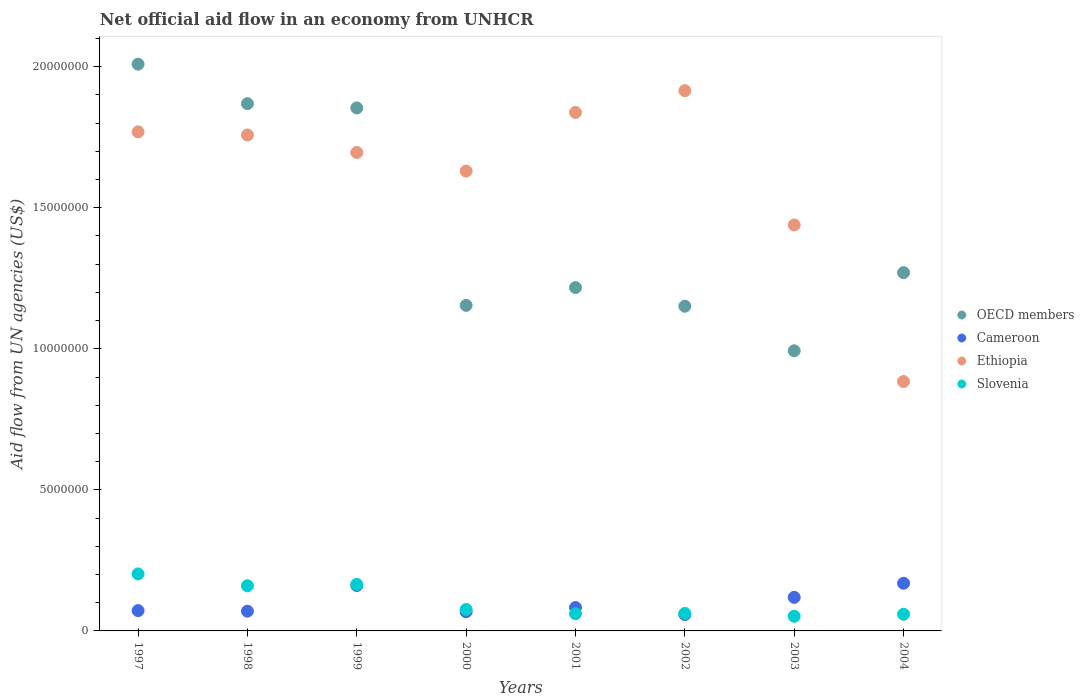Is the number of dotlines equal to the number of legend labels?
Ensure brevity in your answer.  Yes. What is the net official aid flow in Slovenia in 2002?
Keep it short and to the point. 6.20e+05. Across all years, what is the maximum net official aid flow in OECD members?
Your answer should be compact. 2.01e+07. Across all years, what is the minimum net official aid flow in OECD members?
Provide a succinct answer. 9.93e+06. In which year was the net official aid flow in Slovenia maximum?
Make the answer very short. 1997. What is the total net official aid flow in OECD members in the graph?
Provide a succinct answer. 1.15e+08. What is the difference between the net official aid flow in Cameroon in 1999 and that in 2003?
Provide a succinct answer. 4.20e+05. What is the difference between the net official aid flow in Slovenia in 2004 and the net official aid flow in Ethiopia in 1997?
Offer a very short reply. -1.71e+07. In the year 1999, what is the difference between the net official aid flow in OECD members and net official aid flow in Slovenia?
Provide a short and direct response. 1.69e+07. In how many years, is the net official aid flow in Slovenia greater than 10000000 US$?
Ensure brevity in your answer.  0. What is the ratio of the net official aid flow in Cameroon in 1999 to that in 2001?
Provide a short and direct response. 1.94. Is the net official aid flow in Slovenia in 2000 less than that in 2002?
Provide a short and direct response. No. What is the difference between the highest and the second highest net official aid flow in Ethiopia?
Make the answer very short. 7.70e+05. What is the difference between the highest and the lowest net official aid flow in Cameroon?
Make the answer very short. 1.11e+06. Is the sum of the net official aid flow in Cameroon in 1997 and 1998 greater than the maximum net official aid flow in Ethiopia across all years?
Offer a terse response. No. Is it the case that in every year, the sum of the net official aid flow in Slovenia and net official aid flow in OECD members  is greater than the sum of net official aid flow in Cameroon and net official aid flow in Ethiopia?
Your answer should be very brief. Yes. Is it the case that in every year, the sum of the net official aid flow in Slovenia and net official aid flow in Ethiopia  is greater than the net official aid flow in OECD members?
Your response must be concise. No. Is the net official aid flow in Ethiopia strictly greater than the net official aid flow in Cameroon over the years?
Ensure brevity in your answer.  Yes. How many years are there in the graph?
Offer a terse response. 8. Are the values on the major ticks of Y-axis written in scientific E-notation?
Offer a very short reply. No. Where does the legend appear in the graph?
Make the answer very short. Center right. What is the title of the graph?
Provide a succinct answer. Net official aid flow in an economy from UNHCR. Does "Tanzania" appear as one of the legend labels in the graph?
Your response must be concise. No. What is the label or title of the X-axis?
Your answer should be compact. Years. What is the label or title of the Y-axis?
Provide a succinct answer. Aid flow from UN agencies (US$). What is the Aid flow from UN agencies (US$) in OECD members in 1997?
Offer a terse response. 2.01e+07. What is the Aid flow from UN agencies (US$) of Cameroon in 1997?
Your answer should be compact. 7.20e+05. What is the Aid flow from UN agencies (US$) of Ethiopia in 1997?
Your answer should be compact. 1.77e+07. What is the Aid flow from UN agencies (US$) in Slovenia in 1997?
Ensure brevity in your answer.  2.02e+06. What is the Aid flow from UN agencies (US$) in OECD members in 1998?
Provide a succinct answer. 1.87e+07. What is the Aid flow from UN agencies (US$) in Cameroon in 1998?
Keep it short and to the point. 7.00e+05. What is the Aid flow from UN agencies (US$) in Ethiopia in 1998?
Ensure brevity in your answer.  1.76e+07. What is the Aid flow from UN agencies (US$) of Slovenia in 1998?
Your response must be concise. 1.60e+06. What is the Aid flow from UN agencies (US$) in OECD members in 1999?
Ensure brevity in your answer.  1.85e+07. What is the Aid flow from UN agencies (US$) of Cameroon in 1999?
Your answer should be very brief. 1.61e+06. What is the Aid flow from UN agencies (US$) of Ethiopia in 1999?
Keep it short and to the point. 1.70e+07. What is the Aid flow from UN agencies (US$) in Slovenia in 1999?
Give a very brief answer. 1.65e+06. What is the Aid flow from UN agencies (US$) in OECD members in 2000?
Provide a succinct answer. 1.15e+07. What is the Aid flow from UN agencies (US$) of Cameroon in 2000?
Offer a very short reply. 6.80e+05. What is the Aid flow from UN agencies (US$) in Ethiopia in 2000?
Your answer should be compact. 1.63e+07. What is the Aid flow from UN agencies (US$) of Slovenia in 2000?
Provide a succinct answer. 7.60e+05. What is the Aid flow from UN agencies (US$) of OECD members in 2001?
Ensure brevity in your answer.  1.22e+07. What is the Aid flow from UN agencies (US$) in Cameroon in 2001?
Ensure brevity in your answer.  8.30e+05. What is the Aid flow from UN agencies (US$) in Ethiopia in 2001?
Provide a short and direct response. 1.84e+07. What is the Aid flow from UN agencies (US$) in OECD members in 2002?
Offer a terse response. 1.15e+07. What is the Aid flow from UN agencies (US$) in Cameroon in 2002?
Provide a short and direct response. 5.80e+05. What is the Aid flow from UN agencies (US$) in Ethiopia in 2002?
Your answer should be compact. 1.92e+07. What is the Aid flow from UN agencies (US$) in Slovenia in 2002?
Your answer should be compact. 6.20e+05. What is the Aid flow from UN agencies (US$) in OECD members in 2003?
Your answer should be compact. 9.93e+06. What is the Aid flow from UN agencies (US$) of Cameroon in 2003?
Your answer should be very brief. 1.19e+06. What is the Aid flow from UN agencies (US$) in Ethiopia in 2003?
Provide a succinct answer. 1.44e+07. What is the Aid flow from UN agencies (US$) in Slovenia in 2003?
Make the answer very short. 5.20e+05. What is the Aid flow from UN agencies (US$) of OECD members in 2004?
Provide a succinct answer. 1.27e+07. What is the Aid flow from UN agencies (US$) in Cameroon in 2004?
Give a very brief answer. 1.69e+06. What is the Aid flow from UN agencies (US$) of Ethiopia in 2004?
Provide a short and direct response. 8.84e+06. What is the Aid flow from UN agencies (US$) in Slovenia in 2004?
Offer a very short reply. 5.90e+05. Across all years, what is the maximum Aid flow from UN agencies (US$) of OECD members?
Provide a succinct answer. 2.01e+07. Across all years, what is the maximum Aid flow from UN agencies (US$) in Cameroon?
Make the answer very short. 1.69e+06. Across all years, what is the maximum Aid flow from UN agencies (US$) of Ethiopia?
Provide a succinct answer. 1.92e+07. Across all years, what is the maximum Aid flow from UN agencies (US$) of Slovenia?
Offer a very short reply. 2.02e+06. Across all years, what is the minimum Aid flow from UN agencies (US$) in OECD members?
Provide a succinct answer. 9.93e+06. Across all years, what is the minimum Aid flow from UN agencies (US$) of Cameroon?
Your answer should be compact. 5.80e+05. Across all years, what is the minimum Aid flow from UN agencies (US$) in Ethiopia?
Your answer should be compact. 8.84e+06. Across all years, what is the minimum Aid flow from UN agencies (US$) in Slovenia?
Give a very brief answer. 5.20e+05. What is the total Aid flow from UN agencies (US$) in OECD members in the graph?
Ensure brevity in your answer.  1.15e+08. What is the total Aid flow from UN agencies (US$) in Ethiopia in the graph?
Your response must be concise. 1.29e+08. What is the total Aid flow from UN agencies (US$) in Slovenia in the graph?
Offer a very short reply. 8.37e+06. What is the difference between the Aid flow from UN agencies (US$) of OECD members in 1997 and that in 1998?
Provide a short and direct response. 1.40e+06. What is the difference between the Aid flow from UN agencies (US$) in Slovenia in 1997 and that in 1998?
Keep it short and to the point. 4.20e+05. What is the difference between the Aid flow from UN agencies (US$) of OECD members in 1997 and that in 1999?
Provide a succinct answer. 1.55e+06. What is the difference between the Aid flow from UN agencies (US$) in Cameroon in 1997 and that in 1999?
Make the answer very short. -8.90e+05. What is the difference between the Aid flow from UN agencies (US$) in Ethiopia in 1997 and that in 1999?
Ensure brevity in your answer.  7.30e+05. What is the difference between the Aid flow from UN agencies (US$) of OECD members in 1997 and that in 2000?
Offer a very short reply. 8.55e+06. What is the difference between the Aid flow from UN agencies (US$) of Cameroon in 1997 and that in 2000?
Your response must be concise. 4.00e+04. What is the difference between the Aid flow from UN agencies (US$) of Ethiopia in 1997 and that in 2000?
Keep it short and to the point. 1.39e+06. What is the difference between the Aid flow from UN agencies (US$) in Slovenia in 1997 and that in 2000?
Keep it short and to the point. 1.26e+06. What is the difference between the Aid flow from UN agencies (US$) of OECD members in 1997 and that in 2001?
Keep it short and to the point. 7.92e+06. What is the difference between the Aid flow from UN agencies (US$) in Cameroon in 1997 and that in 2001?
Give a very brief answer. -1.10e+05. What is the difference between the Aid flow from UN agencies (US$) of Ethiopia in 1997 and that in 2001?
Ensure brevity in your answer.  -6.90e+05. What is the difference between the Aid flow from UN agencies (US$) in Slovenia in 1997 and that in 2001?
Your response must be concise. 1.41e+06. What is the difference between the Aid flow from UN agencies (US$) of OECD members in 1997 and that in 2002?
Offer a terse response. 8.58e+06. What is the difference between the Aid flow from UN agencies (US$) in Ethiopia in 1997 and that in 2002?
Offer a very short reply. -1.46e+06. What is the difference between the Aid flow from UN agencies (US$) in Slovenia in 1997 and that in 2002?
Offer a terse response. 1.40e+06. What is the difference between the Aid flow from UN agencies (US$) of OECD members in 1997 and that in 2003?
Give a very brief answer. 1.02e+07. What is the difference between the Aid flow from UN agencies (US$) in Cameroon in 1997 and that in 2003?
Provide a succinct answer. -4.70e+05. What is the difference between the Aid flow from UN agencies (US$) in Ethiopia in 1997 and that in 2003?
Provide a succinct answer. 3.30e+06. What is the difference between the Aid flow from UN agencies (US$) in Slovenia in 1997 and that in 2003?
Offer a terse response. 1.50e+06. What is the difference between the Aid flow from UN agencies (US$) of OECD members in 1997 and that in 2004?
Make the answer very short. 7.39e+06. What is the difference between the Aid flow from UN agencies (US$) of Cameroon in 1997 and that in 2004?
Offer a terse response. -9.70e+05. What is the difference between the Aid flow from UN agencies (US$) of Ethiopia in 1997 and that in 2004?
Keep it short and to the point. 8.85e+06. What is the difference between the Aid flow from UN agencies (US$) in Slovenia in 1997 and that in 2004?
Offer a terse response. 1.43e+06. What is the difference between the Aid flow from UN agencies (US$) of OECD members in 1998 and that in 1999?
Your answer should be compact. 1.50e+05. What is the difference between the Aid flow from UN agencies (US$) in Cameroon in 1998 and that in 1999?
Give a very brief answer. -9.10e+05. What is the difference between the Aid flow from UN agencies (US$) of Ethiopia in 1998 and that in 1999?
Make the answer very short. 6.20e+05. What is the difference between the Aid flow from UN agencies (US$) of OECD members in 1998 and that in 2000?
Your response must be concise. 7.15e+06. What is the difference between the Aid flow from UN agencies (US$) in Ethiopia in 1998 and that in 2000?
Your answer should be compact. 1.28e+06. What is the difference between the Aid flow from UN agencies (US$) of Slovenia in 1998 and that in 2000?
Offer a terse response. 8.40e+05. What is the difference between the Aid flow from UN agencies (US$) in OECD members in 1998 and that in 2001?
Your response must be concise. 6.52e+06. What is the difference between the Aid flow from UN agencies (US$) in Cameroon in 1998 and that in 2001?
Keep it short and to the point. -1.30e+05. What is the difference between the Aid flow from UN agencies (US$) in Ethiopia in 1998 and that in 2001?
Make the answer very short. -8.00e+05. What is the difference between the Aid flow from UN agencies (US$) in Slovenia in 1998 and that in 2001?
Your answer should be very brief. 9.90e+05. What is the difference between the Aid flow from UN agencies (US$) in OECD members in 1998 and that in 2002?
Your answer should be very brief. 7.18e+06. What is the difference between the Aid flow from UN agencies (US$) of Ethiopia in 1998 and that in 2002?
Give a very brief answer. -1.57e+06. What is the difference between the Aid flow from UN agencies (US$) in Slovenia in 1998 and that in 2002?
Offer a very short reply. 9.80e+05. What is the difference between the Aid flow from UN agencies (US$) of OECD members in 1998 and that in 2003?
Offer a terse response. 8.76e+06. What is the difference between the Aid flow from UN agencies (US$) in Cameroon in 1998 and that in 2003?
Keep it short and to the point. -4.90e+05. What is the difference between the Aid flow from UN agencies (US$) of Ethiopia in 1998 and that in 2003?
Ensure brevity in your answer.  3.19e+06. What is the difference between the Aid flow from UN agencies (US$) of Slovenia in 1998 and that in 2003?
Give a very brief answer. 1.08e+06. What is the difference between the Aid flow from UN agencies (US$) of OECD members in 1998 and that in 2004?
Ensure brevity in your answer.  5.99e+06. What is the difference between the Aid flow from UN agencies (US$) in Cameroon in 1998 and that in 2004?
Offer a very short reply. -9.90e+05. What is the difference between the Aid flow from UN agencies (US$) in Ethiopia in 1998 and that in 2004?
Your answer should be compact. 8.74e+06. What is the difference between the Aid flow from UN agencies (US$) of Slovenia in 1998 and that in 2004?
Your answer should be very brief. 1.01e+06. What is the difference between the Aid flow from UN agencies (US$) in Cameroon in 1999 and that in 2000?
Your answer should be compact. 9.30e+05. What is the difference between the Aid flow from UN agencies (US$) in Ethiopia in 1999 and that in 2000?
Your answer should be very brief. 6.60e+05. What is the difference between the Aid flow from UN agencies (US$) of Slovenia in 1999 and that in 2000?
Your answer should be compact. 8.90e+05. What is the difference between the Aid flow from UN agencies (US$) of OECD members in 1999 and that in 2001?
Provide a short and direct response. 6.37e+06. What is the difference between the Aid flow from UN agencies (US$) of Cameroon in 1999 and that in 2001?
Your answer should be very brief. 7.80e+05. What is the difference between the Aid flow from UN agencies (US$) of Ethiopia in 1999 and that in 2001?
Ensure brevity in your answer.  -1.42e+06. What is the difference between the Aid flow from UN agencies (US$) in Slovenia in 1999 and that in 2001?
Your answer should be very brief. 1.04e+06. What is the difference between the Aid flow from UN agencies (US$) in OECD members in 1999 and that in 2002?
Ensure brevity in your answer.  7.03e+06. What is the difference between the Aid flow from UN agencies (US$) of Cameroon in 1999 and that in 2002?
Make the answer very short. 1.03e+06. What is the difference between the Aid flow from UN agencies (US$) in Ethiopia in 1999 and that in 2002?
Offer a terse response. -2.19e+06. What is the difference between the Aid flow from UN agencies (US$) of Slovenia in 1999 and that in 2002?
Your answer should be very brief. 1.03e+06. What is the difference between the Aid flow from UN agencies (US$) in OECD members in 1999 and that in 2003?
Provide a succinct answer. 8.61e+06. What is the difference between the Aid flow from UN agencies (US$) of Ethiopia in 1999 and that in 2003?
Your answer should be compact. 2.57e+06. What is the difference between the Aid flow from UN agencies (US$) in Slovenia in 1999 and that in 2003?
Provide a short and direct response. 1.13e+06. What is the difference between the Aid flow from UN agencies (US$) of OECD members in 1999 and that in 2004?
Your answer should be compact. 5.84e+06. What is the difference between the Aid flow from UN agencies (US$) of Cameroon in 1999 and that in 2004?
Your response must be concise. -8.00e+04. What is the difference between the Aid flow from UN agencies (US$) in Ethiopia in 1999 and that in 2004?
Ensure brevity in your answer.  8.12e+06. What is the difference between the Aid flow from UN agencies (US$) of Slovenia in 1999 and that in 2004?
Provide a short and direct response. 1.06e+06. What is the difference between the Aid flow from UN agencies (US$) of OECD members in 2000 and that in 2001?
Provide a short and direct response. -6.30e+05. What is the difference between the Aid flow from UN agencies (US$) in Ethiopia in 2000 and that in 2001?
Make the answer very short. -2.08e+06. What is the difference between the Aid flow from UN agencies (US$) of Cameroon in 2000 and that in 2002?
Provide a short and direct response. 1.00e+05. What is the difference between the Aid flow from UN agencies (US$) of Ethiopia in 2000 and that in 2002?
Offer a very short reply. -2.85e+06. What is the difference between the Aid flow from UN agencies (US$) in OECD members in 2000 and that in 2003?
Your response must be concise. 1.61e+06. What is the difference between the Aid flow from UN agencies (US$) of Cameroon in 2000 and that in 2003?
Offer a very short reply. -5.10e+05. What is the difference between the Aid flow from UN agencies (US$) of Ethiopia in 2000 and that in 2003?
Give a very brief answer. 1.91e+06. What is the difference between the Aid flow from UN agencies (US$) of OECD members in 2000 and that in 2004?
Your answer should be very brief. -1.16e+06. What is the difference between the Aid flow from UN agencies (US$) of Cameroon in 2000 and that in 2004?
Keep it short and to the point. -1.01e+06. What is the difference between the Aid flow from UN agencies (US$) of Ethiopia in 2000 and that in 2004?
Offer a very short reply. 7.46e+06. What is the difference between the Aid flow from UN agencies (US$) of Slovenia in 2000 and that in 2004?
Provide a succinct answer. 1.70e+05. What is the difference between the Aid flow from UN agencies (US$) in Ethiopia in 2001 and that in 2002?
Ensure brevity in your answer.  -7.70e+05. What is the difference between the Aid flow from UN agencies (US$) in OECD members in 2001 and that in 2003?
Provide a succinct answer. 2.24e+06. What is the difference between the Aid flow from UN agencies (US$) in Cameroon in 2001 and that in 2003?
Make the answer very short. -3.60e+05. What is the difference between the Aid flow from UN agencies (US$) in Ethiopia in 2001 and that in 2003?
Keep it short and to the point. 3.99e+06. What is the difference between the Aid flow from UN agencies (US$) in OECD members in 2001 and that in 2004?
Provide a short and direct response. -5.30e+05. What is the difference between the Aid flow from UN agencies (US$) in Cameroon in 2001 and that in 2004?
Keep it short and to the point. -8.60e+05. What is the difference between the Aid flow from UN agencies (US$) of Ethiopia in 2001 and that in 2004?
Your answer should be compact. 9.54e+06. What is the difference between the Aid flow from UN agencies (US$) of Slovenia in 2001 and that in 2004?
Give a very brief answer. 2.00e+04. What is the difference between the Aid flow from UN agencies (US$) in OECD members in 2002 and that in 2003?
Ensure brevity in your answer.  1.58e+06. What is the difference between the Aid flow from UN agencies (US$) of Cameroon in 2002 and that in 2003?
Offer a very short reply. -6.10e+05. What is the difference between the Aid flow from UN agencies (US$) of Ethiopia in 2002 and that in 2003?
Ensure brevity in your answer.  4.76e+06. What is the difference between the Aid flow from UN agencies (US$) in OECD members in 2002 and that in 2004?
Provide a short and direct response. -1.19e+06. What is the difference between the Aid flow from UN agencies (US$) in Cameroon in 2002 and that in 2004?
Provide a succinct answer. -1.11e+06. What is the difference between the Aid flow from UN agencies (US$) in Ethiopia in 2002 and that in 2004?
Keep it short and to the point. 1.03e+07. What is the difference between the Aid flow from UN agencies (US$) of Slovenia in 2002 and that in 2004?
Provide a succinct answer. 3.00e+04. What is the difference between the Aid flow from UN agencies (US$) of OECD members in 2003 and that in 2004?
Your response must be concise. -2.77e+06. What is the difference between the Aid flow from UN agencies (US$) of Cameroon in 2003 and that in 2004?
Your answer should be compact. -5.00e+05. What is the difference between the Aid flow from UN agencies (US$) in Ethiopia in 2003 and that in 2004?
Offer a terse response. 5.55e+06. What is the difference between the Aid flow from UN agencies (US$) of OECD members in 1997 and the Aid flow from UN agencies (US$) of Cameroon in 1998?
Offer a very short reply. 1.94e+07. What is the difference between the Aid flow from UN agencies (US$) of OECD members in 1997 and the Aid flow from UN agencies (US$) of Ethiopia in 1998?
Give a very brief answer. 2.51e+06. What is the difference between the Aid flow from UN agencies (US$) of OECD members in 1997 and the Aid flow from UN agencies (US$) of Slovenia in 1998?
Provide a succinct answer. 1.85e+07. What is the difference between the Aid flow from UN agencies (US$) of Cameroon in 1997 and the Aid flow from UN agencies (US$) of Ethiopia in 1998?
Give a very brief answer. -1.69e+07. What is the difference between the Aid flow from UN agencies (US$) in Cameroon in 1997 and the Aid flow from UN agencies (US$) in Slovenia in 1998?
Your answer should be very brief. -8.80e+05. What is the difference between the Aid flow from UN agencies (US$) of Ethiopia in 1997 and the Aid flow from UN agencies (US$) of Slovenia in 1998?
Your answer should be compact. 1.61e+07. What is the difference between the Aid flow from UN agencies (US$) of OECD members in 1997 and the Aid flow from UN agencies (US$) of Cameroon in 1999?
Offer a terse response. 1.85e+07. What is the difference between the Aid flow from UN agencies (US$) of OECD members in 1997 and the Aid flow from UN agencies (US$) of Ethiopia in 1999?
Offer a very short reply. 3.13e+06. What is the difference between the Aid flow from UN agencies (US$) in OECD members in 1997 and the Aid flow from UN agencies (US$) in Slovenia in 1999?
Your answer should be compact. 1.84e+07. What is the difference between the Aid flow from UN agencies (US$) of Cameroon in 1997 and the Aid flow from UN agencies (US$) of Ethiopia in 1999?
Your response must be concise. -1.62e+07. What is the difference between the Aid flow from UN agencies (US$) of Cameroon in 1997 and the Aid flow from UN agencies (US$) of Slovenia in 1999?
Your response must be concise. -9.30e+05. What is the difference between the Aid flow from UN agencies (US$) of Ethiopia in 1997 and the Aid flow from UN agencies (US$) of Slovenia in 1999?
Provide a short and direct response. 1.60e+07. What is the difference between the Aid flow from UN agencies (US$) in OECD members in 1997 and the Aid flow from UN agencies (US$) in Cameroon in 2000?
Provide a short and direct response. 1.94e+07. What is the difference between the Aid flow from UN agencies (US$) of OECD members in 1997 and the Aid flow from UN agencies (US$) of Ethiopia in 2000?
Your answer should be very brief. 3.79e+06. What is the difference between the Aid flow from UN agencies (US$) in OECD members in 1997 and the Aid flow from UN agencies (US$) in Slovenia in 2000?
Offer a terse response. 1.93e+07. What is the difference between the Aid flow from UN agencies (US$) in Cameroon in 1997 and the Aid flow from UN agencies (US$) in Ethiopia in 2000?
Your answer should be compact. -1.56e+07. What is the difference between the Aid flow from UN agencies (US$) of Cameroon in 1997 and the Aid flow from UN agencies (US$) of Slovenia in 2000?
Your response must be concise. -4.00e+04. What is the difference between the Aid flow from UN agencies (US$) of Ethiopia in 1997 and the Aid flow from UN agencies (US$) of Slovenia in 2000?
Give a very brief answer. 1.69e+07. What is the difference between the Aid flow from UN agencies (US$) of OECD members in 1997 and the Aid flow from UN agencies (US$) of Cameroon in 2001?
Provide a short and direct response. 1.93e+07. What is the difference between the Aid flow from UN agencies (US$) in OECD members in 1997 and the Aid flow from UN agencies (US$) in Ethiopia in 2001?
Your response must be concise. 1.71e+06. What is the difference between the Aid flow from UN agencies (US$) of OECD members in 1997 and the Aid flow from UN agencies (US$) of Slovenia in 2001?
Provide a succinct answer. 1.95e+07. What is the difference between the Aid flow from UN agencies (US$) in Cameroon in 1997 and the Aid flow from UN agencies (US$) in Ethiopia in 2001?
Your answer should be very brief. -1.77e+07. What is the difference between the Aid flow from UN agencies (US$) of Cameroon in 1997 and the Aid flow from UN agencies (US$) of Slovenia in 2001?
Offer a terse response. 1.10e+05. What is the difference between the Aid flow from UN agencies (US$) in Ethiopia in 1997 and the Aid flow from UN agencies (US$) in Slovenia in 2001?
Your answer should be compact. 1.71e+07. What is the difference between the Aid flow from UN agencies (US$) of OECD members in 1997 and the Aid flow from UN agencies (US$) of Cameroon in 2002?
Make the answer very short. 1.95e+07. What is the difference between the Aid flow from UN agencies (US$) in OECD members in 1997 and the Aid flow from UN agencies (US$) in Ethiopia in 2002?
Offer a very short reply. 9.40e+05. What is the difference between the Aid flow from UN agencies (US$) in OECD members in 1997 and the Aid flow from UN agencies (US$) in Slovenia in 2002?
Keep it short and to the point. 1.95e+07. What is the difference between the Aid flow from UN agencies (US$) in Cameroon in 1997 and the Aid flow from UN agencies (US$) in Ethiopia in 2002?
Keep it short and to the point. -1.84e+07. What is the difference between the Aid flow from UN agencies (US$) in Cameroon in 1997 and the Aid flow from UN agencies (US$) in Slovenia in 2002?
Keep it short and to the point. 1.00e+05. What is the difference between the Aid flow from UN agencies (US$) in Ethiopia in 1997 and the Aid flow from UN agencies (US$) in Slovenia in 2002?
Provide a succinct answer. 1.71e+07. What is the difference between the Aid flow from UN agencies (US$) of OECD members in 1997 and the Aid flow from UN agencies (US$) of Cameroon in 2003?
Your response must be concise. 1.89e+07. What is the difference between the Aid flow from UN agencies (US$) of OECD members in 1997 and the Aid flow from UN agencies (US$) of Ethiopia in 2003?
Make the answer very short. 5.70e+06. What is the difference between the Aid flow from UN agencies (US$) in OECD members in 1997 and the Aid flow from UN agencies (US$) in Slovenia in 2003?
Your answer should be compact. 1.96e+07. What is the difference between the Aid flow from UN agencies (US$) in Cameroon in 1997 and the Aid flow from UN agencies (US$) in Ethiopia in 2003?
Provide a succinct answer. -1.37e+07. What is the difference between the Aid flow from UN agencies (US$) of Cameroon in 1997 and the Aid flow from UN agencies (US$) of Slovenia in 2003?
Ensure brevity in your answer.  2.00e+05. What is the difference between the Aid flow from UN agencies (US$) in Ethiopia in 1997 and the Aid flow from UN agencies (US$) in Slovenia in 2003?
Your response must be concise. 1.72e+07. What is the difference between the Aid flow from UN agencies (US$) in OECD members in 1997 and the Aid flow from UN agencies (US$) in Cameroon in 2004?
Provide a short and direct response. 1.84e+07. What is the difference between the Aid flow from UN agencies (US$) in OECD members in 1997 and the Aid flow from UN agencies (US$) in Ethiopia in 2004?
Give a very brief answer. 1.12e+07. What is the difference between the Aid flow from UN agencies (US$) in OECD members in 1997 and the Aid flow from UN agencies (US$) in Slovenia in 2004?
Provide a short and direct response. 1.95e+07. What is the difference between the Aid flow from UN agencies (US$) in Cameroon in 1997 and the Aid flow from UN agencies (US$) in Ethiopia in 2004?
Provide a short and direct response. -8.12e+06. What is the difference between the Aid flow from UN agencies (US$) in Ethiopia in 1997 and the Aid flow from UN agencies (US$) in Slovenia in 2004?
Your answer should be very brief. 1.71e+07. What is the difference between the Aid flow from UN agencies (US$) of OECD members in 1998 and the Aid flow from UN agencies (US$) of Cameroon in 1999?
Ensure brevity in your answer.  1.71e+07. What is the difference between the Aid flow from UN agencies (US$) in OECD members in 1998 and the Aid flow from UN agencies (US$) in Ethiopia in 1999?
Provide a short and direct response. 1.73e+06. What is the difference between the Aid flow from UN agencies (US$) of OECD members in 1998 and the Aid flow from UN agencies (US$) of Slovenia in 1999?
Offer a terse response. 1.70e+07. What is the difference between the Aid flow from UN agencies (US$) in Cameroon in 1998 and the Aid flow from UN agencies (US$) in Ethiopia in 1999?
Give a very brief answer. -1.63e+07. What is the difference between the Aid flow from UN agencies (US$) of Cameroon in 1998 and the Aid flow from UN agencies (US$) of Slovenia in 1999?
Offer a very short reply. -9.50e+05. What is the difference between the Aid flow from UN agencies (US$) of Ethiopia in 1998 and the Aid flow from UN agencies (US$) of Slovenia in 1999?
Provide a short and direct response. 1.59e+07. What is the difference between the Aid flow from UN agencies (US$) of OECD members in 1998 and the Aid flow from UN agencies (US$) of Cameroon in 2000?
Provide a succinct answer. 1.80e+07. What is the difference between the Aid flow from UN agencies (US$) in OECD members in 1998 and the Aid flow from UN agencies (US$) in Ethiopia in 2000?
Provide a short and direct response. 2.39e+06. What is the difference between the Aid flow from UN agencies (US$) in OECD members in 1998 and the Aid flow from UN agencies (US$) in Slovenia in 2000?
Your answer should be very brief. 1.79e+07. What is the difference between the Aid flow from UN agencies (US$) of Cameroon in 1998 and the Aid flow from UN agencies (US$) of Ethiopia in 2000?
Offer a very short reply. -1.56e+07. What is the difference between the Aid flow from UN agencies (US$) of Cameroon in 1998 and the Aid flow from UN agencies (US$) of Slovenia in 2000?
Your response must be concise. -6.00e+04. What is the difference between the Aid flow from UN agencies (US$) of Ethiopia in 1998 and the Aid flow from UN agencies (US$) of Slovenia in 2000?
Provide a succinct answer. 1.68e+07. What is the difference between the Aid flow from UN agencies (US$) in OECD members in 1998 and the Aid flow from UN agencies (US$) in Cameroon in 2001?
Give a very brief answer. 1.79e+07. What is the difference between the Aid flow from UN agencies (US$) in OECD members in 1998 and the Aid flow from UN agencies (US$) in Slovenia in 2001?
Your answer should be very brief. 1.81e+07. What is the difference between the Aid flow from UN agencies (US$) in Cameroon in 1998 and the Aid flow from UN agencies (US$) in Ethiopia in 2001?
Keep it short and to the point. -1.77e+07. What is the difference between the Aid flow from UN agencies (US$) in Cameroon in 1998 and the Aid flow from UN agencies (US$) in Slovenia in 2001?
Your answer should be compact. 9.00e+04. What is the difference between the Aid flow from UN agencies (US$) of Ethiopia in 1998 and the Aid flow from UN agencies (US$) of Slovenia in 2001?
Your answer should be very brief. 1.70e+07. What is the difference between the Aid flow from UN agencies (US$) of OECD members in 1998 and the Aid flow from UN agencies (US$) of Cameroon in 2002?
Give a very brief answer. 1.81e+07. What is the difference between the Aid flow from UN agencies (US$) of OECD members in 1998 and the Aid flow from UN agencies (US$) of Ethiopia in 2002?
Your answer should be very brief. -4.60e+05. What is the difference between the Aid flow from UN agencies (US$) in OECD members in 1998 and the Aid flow from UN agencies (US$) in Slovenia in 2002?
Ensure brevity in your answer.  1.81e+07. What is the difference between the Aid flow from UN agencies (US$) of Cameroon in 1998 and the Aid flow from UN agencies (US$) of Ethiopia in 2002?
Keep it short and to the point. -1.84e+07. What is the difference between the Aid flow from UN agencies (US$) in Ethiopia in 1998 and the Aid flow from UN agencies (US$) in Slovenia in 2002?
Make the answer very short. 1.70e+07. What is the difference between the Aid flow from UN agencies (US$) in OECD members in 1998 and the Aid flow from UN agencies (US$) in Cameroon in 2003?
Offer a very short reply. 1.75e+07. What is the difference between the Aid flow from UN agencies (US$) of OECD members in 1998 and the Aid flow from UN agencies (US$) of Ethiopia in 2003?
Your response must be concise. 4.30e+06. What is the difference between the Aid flow from UN agencies (US$) of OECD members in 1998 and the Aid flow from UN agencies (US$) of Slovenia in 2003?
Your answer should be compact. 1.82e+07. What is the difference between the Aid flow from UN agencies (US$) in Cameroon in 1998 and the Aid flow from UN agencies (US$) in Ethiopia in 2003?
Provide a short and direct response. -1.37e+07. What is the difference between the Aid flow from UN agencies (US$) of Ethiopia in 1998 and the Aid flow from UN agencies (US$) of Slovenia in 2003?
Provide a succinct answer. 1.71e+07. What is the difference between the Aid flow from UN agencies (US$) in OECD members in 1998 and the Aid flow from UN agencies (US$) in Cameroon in 2004?
Your answer should be very brief. 1.70e+07. What is the difference between the Aid flow from UN agencies (US$) in OECD members in 1998 and the Aid flow from UN agencies (US$) in Ethiopia in 2004?
Ensure brevity in your answer.  9.85e+06. What is the difference between the Aid flow from UN agencies (US$) of OECD members in 1998 and the Aid flow from UN agencies (US$) of Slovenia in 2004?
Ensure brevity in your answer.  1.81e+07. What is the difference between the Aid flow from UN agencies (US$) in Cameroon in 1998 and the Aid flow from UN agencies (US$) in Ethiopia in 2004?
Offer a terse response. -8.14e+06. What is the difference between the Aid flow from UN agencies (US$) of Ethiopia in 1998 and the Aid flow from UN agencies (US$) of Slovenia in 2004?
Ensure brevity in your answer.  1.70e+07. What is the difference between the Aid flow from UN agencies (US$) in OECD members in 1999 and the Aid flow from UN agencies (US$) in Cameroon in 2000?
Your answer should be very brief. 1.79e+07. What is the difference between the Aid flow from UN agencies (US$) of OECD members in 1999 and the Aid flow from UN agencies (US$) of Ethiopia in 2000?
Offer a terse response. 2.24e+06. What is the difference between the Aid flow from UN agencies (US$) in OECD members in 1999 and the Aid flow from UN agencies (US$) in Slovenia in 2000?
Ensure brevity in your answer.  1.78e+07. What is the difference between the Aid flow from UN agencies (US$) of Cameroon in 1999 and the Aid flow from UN agencies (US$) of Ethiopia in 2000?
Provide a short and direct response. -1.47e+07. What is the difference between the Aid flow from UN agencies (US$) in Cameroon in 1999 and the Aid flow from UN agencies (US$) in Slovenia in 2000?
Make the answer very short. 8.50e+05. What is the difference between the Aid flow from UN agencies (US$) in Ethiopia in 1999 and the Aid flow from UN agencies (US$) in Slovenia in 2000?
Offer a very short reply. 1.62e+07. What is the difference between the Aid flow from UN agencies (US$) in OECD members in 1999 and the Aid flow from UN agencies (US$) in Cameroon in 2001?
Offer a terse response. 1.77e+07. What is the difference between the Aid flow from UN agencies (US$) in OECD members in 1999 and the Aid flow from UN agencies (US$) in Ethiopia in 2001?
Offer a terse response. 1.60e+05. What is the difference between the Aid flow from UN agencies (US$) in OECD members in 1999 and the Aid flow from UN agencies (US$) in Slovenia in 2001?
Your response must be concise. 1.79e+07. What is the difference between the Aid flow from UN agencies (US$) of Cameroon in 1999 and the Aid flow from UN agencies (US$) of Ethiopia in 2001?
Offer a very short reply. -1.68e+07. What is the difference between the Aid flow from UN agencies (US$) in Cameroon in 1999 and the Aid flow from UN agencies (US$) in Slovenia in 2001?
Offer a terse response. 1.00e+06. What is the difference between the Aid flow from UN agencies (US$) in Ethiopia in 1999 and the Aid flow from UN agencies (US$) in Slovenia in 2001?
Provide a succinct answer. 1.64e+07. What is the difference between the Aid flow from UN agencies (US$) of OECD members in 1999 and the Aid flow from UN agencies (US$) of Cameroon in 2002?
Provide a short and direct response. 1.80e+07. What is the difference between the Aid flow from UN agencies (US$) in OECD members in 1999 and the Aid flow from UN agencies (US$) in Ethiopia in 2002?
Provide a short and direct response. -6.10e+05. What is the difference between the Aid flow from UN agencies (US$) in OECD members in 1999 and the Aid flow from UN agencies (US$) in Slovenia in 2002?
Your answer should be very brief. 1.79e+07. What is the difference between the Aid flow from UN agencies (US$) of Cameroon in 1999 and the Aid flow from UN agencies (US$) of Ethiopia in 2002?
Offer a terse response. -1.75e+07. What is the difference between the Aid flow from UN agencies (US$) of Cameroon in 1999 and the Aid flow from UN agencies (US$) of Slovenia in 2002?
Make the answer very short. 9.90e+05. What is the difference between the Aid flow from UN agencies (US$) of Ethiopia in 1999 and the Aid flow from UN agencies (US$) of Slovenia in 2002?
Keep it short and to the point. 1.63e+07. What is the difference between the Aid flow from UN agencies (US$) in OECD members in 1999 and the Aid flow from UN agencies (US$) in Cameroon in 2003?
Offer a very short reply. 1.74e+07. What is the difference between the Aid flow from UN agencies (US$) in OECD members in 1999 and the Aid flow from UN agencies (US$) in Ethiopia in 2003?
Offer a very short reply. 4.15e+06. What is the difference between the Aid flow from UN agencies (US$) of OECD members in 1999 and the Aid flow from UN agencies (US$) of Slovenia in 2003?
Give a very brief answer. 1.80e+07. What is the difference between the Aid flow from UN agencies (US$) in Cameroon in 1999 and the Aid flow from UN agencies (US$) in Ethiopia in 2003?
Offer a very short reply. -1.28e+07. What is the difference between the Aid flow from UN agencies (US$) in Cameroon in 1999 and the Aid flow from UN agencies (US$) in Slovenia in 2003?
Give a very brief answer. 1.09e+06. What is the difference between the Aid flow from UN agencies (US$) of Ethiopia in 1999 and the Aid flow from UN agencies (US$) of Slovenia in 2003?
Offer a terse response. 1.64e+07. What is the difference between the Aid flow from UN agencies (US$) in OECD members in 1999 and the Aid flow from UN agencies (US$) in Cameroon in 2004?
Your response must be concise. 1.68e+07. What is the difference between the Aid flow from UN agencies (US$) of OECD members in 1999 and the Aid flow from UN agencies (US$) of Ethiopia in 2004?
Offer a very short reply. 9.70e+06. What is the difference between the Aid flow from UN agencies (US$) of OECD members in 1999 and the Aid flow from UN agencies (US$) of Slovenia in 2004?
Make the answer very short. 1.80e+07. What is the difference between the Aid flow from UN agencies (US$) of Cameroon in 1999 and the Aid flow from UN agencies (US$) of Ethiopia in 2004?
Ensure brevity in your answer.  -7.23e+06. What is the difference between the Aid flow from UN agencies (US$) in Cameroon in 1999 and the Aid flow from UN agencies (US$) in Slovenia in 2004?
Provide a succinct answer. 1.02e+06. What is the difference between the Aid flow from UN agencies (US$) in Ethiopia in 1999 and the Aid flow from UN agencies (US$) in Slovenia in 2004?
Your answer should be very brief. 1.64e+07. What is the difference between the Aid flow from UN agencies (US$) of OECD members in 2000 and the Aid flow from UN agencies (US$) of Cameroon in 2001?
Offer a terse response. 1.07e+07. What is the difference between the Aid flow from UN agencies (US$) of OECD members in 2000 and the Aid flow from UN agencies (US$) of Ethiopia in 2001?
Your answer should be compact. -6.84e+06. What is the difference between the Aid flow from UN agencies (US$) of OECD members in 2000 and the Aid flow from UN agencies (US$) of Slovenia in 2001?
Offer a terse response. 1.09e+07. What is the difference between the Aid flow from UN agencies (US$) of Cameroon in 2000 and the Aid flow from UN agencies (US$) of Ethiopia in 2001?
Make the answer very short. -1.77e+07. What is the difference between the Aid flow from UN agencies (US$) in Ethiopia in 2000 and the Aid flow from UN agencies (US$) in Slovenia in 2001?
Ensure brevity in your answer.  1.57e+07. What is the difference between the Aid flow from UN agencies (US$) of OECD members in 2000 and the Aid flow from UN agencies (US$) of Cameroon in 2002?
Provide a succinct answer. 1.10e+07. What is the difference between the Aid flow from UN agencies (US$) in OECD members in 2000 and the Aid flow from UN agencies (US$) in Ethiopia in 2002?
Your response must be concise. -7.61e+06. What is the difference between the Aid flow from UN agencies (US$) of OECD members in 2000 and the Aid flow from UN agencies (US$) of Slovenia in 2002?
Provide a short and direct response. 1.09e+07. What is the difference between the Aid flow from UN agencies (US$) of Cameroon in 2000 and the Aid flow from UN agencies (US$) of Ethiopia in 2002?
Ensure brevity in your answer.  -1.85e+07. What is the difference between the Aid flow from UN agencies (US$) of Ethiopia in 2000 and the Aid flow from UN agencies (US$) of Slovenia in 2002?
Keep it short and to the point. 1.57e+07. What is the difference between the Aid flow from UN agencies (US$) in OECD members in 2000 and the Aid flow from UN agencies (US$) in Cameroon in 2003?
Give a very brief answer. 1.04e+07. What is the difference between the Aid flow from UN agencies (US$) of OECD members in 2000 and the Aid flow from UN agencies (US$) of Ethiopia in 2003?
Offer a very short reply. -2.85e+06. What is the difference between the Aid flow from UN agencies (US$) in OECD members in 2000 and the Aid flow from UN agencies (US$) in Slovenia in 2003?
Your answer should be very brief. 1.10e+07. What is the difference between the Aid flow from UN agencies (US$) of Cameroon in 2000 and the Aid flow from UN agencies (US$) of Ethiopia in 2003?
Your response must be concise. -1.37e+07. What is the difference between the Aid flow from UN agencies (US$) in Ethiopia in 2000 and the Aid flow from UN agencies (US$) in Slovenia in 2003?
Give a very brief answer. 1.58e+07. What is the difference between the Aid flow from UN agencies (US$) of OECD members in 2000 and the Aid flow from UN agencies (US$) of Cameroon in 2004?
Your answer should be compact. 9.85e+06. What is the difference between the Aid flow from UN agencies (US$) in OECD members in 2000 and the Aid flow from UN agencies (US$) in Ethiopia in 2004?
Offer a terse response. 2.70e+06. What is the difference between the Aid flow from UN agencies (US$) in OECD members in 2000 and the Aid flow from UN agencies (US$) in Slovenia in 2004?
Keep it short and to the point. 1.10e+07. What is the difference between the Aid flow from UN agencies (US$) of Cameroon in 2000 and the Aid flow from UN agencies (US$) of Ethiopia in 2004?
Make the answer very short. -8.16e+06. What is the difference between the Aid flow from UN agencies (US$) in Cameroon in 2000 and the Aid flow from UN agencies (US$) in Slovenia in 2004?
Your response must be concise. 9.00e+04. What is the difference between the Aid flow from UN agencies (US$) in Ethiopia in 2000 and the Aid flow from UN agencies (US$) in Slovenia in 2004?
Keep it short and to the point. 1.57e+07. What is the difference between the Aid flow from UN agencies (US$) of OECD members in 2001 and the Aid flow from UN agencies (US$) of Cameroon in 2002?
Your response must be concise. 1.16e+07. What is the difference between the Aid flow from UN agencies (US$) in OECD members in 2001 and the Aid flow from UN agencies (US$) in Ethiopia in 2002?
Provide a short and direct response. -6.98e+06. What is the difference between the Aid flow from UN agencies (US$) of OECD members in 2001 and the Aid flow from UN agencies (US$) of Slovenia in 2002?
Give a very brief answer. 1.16e+07. What is the difference between the Aid flow from UN agencies (US$) in Cameroon in 2001 and the Aid flow from UN agencies (US$) in Ethiopia in 2002?
Ensure brevity in your answer.  -1.83e+07. What is the difference between the Aid flow from UN agencies (US$) in Ethiopia in 2001 and the Aid flow from UN agencies (US$) in Slovenia in 2002?
Provide a short and direct response. 1.78e+07. What is the difference between the Aid flow from UN agencies (US$) in OECD members in 2001 and the Aid flow from UN agencies (US$) in Cameroon in 2003?
Keep it short and to the point. 1.10e+07. What is the difference between the Aid flow from UN agencies (US$) of OECD members in 2001 and the Aid flow from UN agencies (US$) of Ethiopia in 2003?
Give a very brief answer. -2.22e+06. What is the difference between the Aid flow from UN agencies (US$) in OECD members in 2001 and the Aid flow from UN agencies (US$) in Slovenia in 2003?
Ensure brevity in your answer.  1.16e+07. What is the difference between the Aid flow from UN agencies (US$) of Cameroon in 2001 and the Aid flow from UN agencies (US$) of Ethiopia in 2003?
Offer a very short reply. -1.36e+07. What is the difference between the Aid flow from UN agencies (US$) in Cameroon in 2001 and the Aid flow from UN agencies (US$) in Slovenia in 2003?
Offer a terse response. 3.10e+05. What is the difference between the Aid flow from UN agencies (US$) in Ethiopia in 2001 and the Aid flow from UN agencies (US$) in Slovenia in 2003?
Offer a terse response. 1.79e+07. What is the difference between the Aid flow from UN agencies (US$) of OECD members in 2001 and the Aid flow from UN agencies (US$) of Cameroon in 2004?
Keep it short and to the point. 1.05e+07. What is the difference between the Aid flow from UN agencies (US$) in OECD members in 2001 and the Aid flow from UN agencies (US$) in Ethiopia in 2004?
Provide a short and direct response. 3.33e+06. What is the difference between the Aid flow from UN agencies (US$) in OECD members in 2001 and the Aid flow from UN agencies (US$) in Slovenia in 2004?
Keep it short and to the point. 1.16e+07. What is the difference between the Aid flow from UN agencies (US$) of Cameroon in 2001 and the Aid flow from UN agencies (US$) of Ethiopia in 2004?
Give a very brief answer. -8.01e+06. What is the difference between the Aid flow from UN agencies (US$) of Cameroon in 2001 and the Aid flow from UN agencies (US$) of Slovenia in 2004?
Offer a very short reply. 2.40e+05. What is the difference between the Aid flow from UN agencies (US$) in Ethiopia in 2001 and the Aid flow from UN agencies (US$) in Slovenia in 2004?
Offer a terse response. 1.78e+07. What is the difference between the Aid flow from UN agencies (US$) of OECD members in 2002 and the Aid flow from UN agencies (US$) of Cameroon in 2003?
Provide a succinct answer. 1.03e+07. What is the difference between the Aid flow from UN agencies (US$) in OECD members in 2002 and the Aid flow from UN agencies (US$) in Ethiopia in 2003?
Your response must be concise. -2.88e+06. What is the difference between the Aid flow from UN agencies (US$) in OECD members in 2002 and the Aid flow from UN agencies (US$) in Slovenia in 2003?
Your response must be concise. 1.10e+07. What is the difference between the Aid flow from UN agencies (US$) of Cameroon in 2002 and the Aid flow from UN agencies (US$) of Ethiopia in 2003?
Offer a terse response. -1.38e+07. What is the difference between the Aid flow from UN agencies (US$) of Ethiopia in 2002 and the Aid flow from UN agencies (US$) of Slovenia in 2003?
Provide a short and direct response. 1.86e+07. What is the difference between the Aid flow from UN agencies (US$) in OECD members in 2002 and the Aid flow from UN agencies (US$) in Cameroon in 2004?
Give a very brief answer. 9.82e+06. What is the difference between the Aid flow from UN agencies (US$) in OECD members in 2002 and the Aid flow from UN agencies (US$) in Ethiopia in 2004?
Keep it short and to the point. 2.67e+06. What is the difference between the Aid flow from UN agencies (US$) of OECD members in 2002 and the Aid flow from UN agencies (US$) of Slovenia in 2004?
Keep it short and to the point. 1.09e+07. What is the difference between the Aid flow from UN agencies (US$) of Cameroon in 2002 and the Aid flow from UN agencies (US$) of Ethiopia in 2004?
Provide a succinct answer. -8.26e+06. What is the difference between the Aid flow from UN agencies (US$) of Ethiopia in 2002 and the Aid flow from UN agencies (US$) of Slovenia in 2004?
Give a very brief answer. 1.86e+07. What is the difference between the Aid flow from UN agencies (US$) in OECD members in 2003 and the Aid flow from UN agencies (US$) in Cameroon in 2004?
Your answer should be compact. 8.24e+06. What is the difference between the Aid flow from UN agencies (US$) of OECD members in 2003 and the Aid flow from UN agencies (US$) of Ethiopia in 2004?
Provide a succinct answer. 1.09e+06. What is the difference between the Aid flow from UN agencies (US$) of OECD members in 2003 and the Aid flow from UN agencies (US$) of Slovenia in 2004?
Your response must be concise. 9.34e+06. What is the difference between the Aid flow from UN agencies (US$) of Cameroon in 2003 and the Aid flow from UN agencies (US$) of Ethiopia in 2004?
Your answer should be very brief. -7.65e+06. What is the difference between the Aid flow from UN agencies (US$) in Cameroon in 2003 and the Aid flow from UN agencies (US$) in Slovenia in 2004?
Your response must be concise. 6.00e+05. What is the difference between the Aid flow from UN agencies (US$) of Ethiopia in 2003 and the Aid flow from UN agencies (US$) of Slovenia in 2004?
Make the answer very short. 1.38e+07. What is the average Aid flow from UN agencies (US$) in OECD members per year?
Keep it short and to the point. 1.44e+07. What is the average Aid flow from UN agencies (US$) of Cameroon per year?
Ensure brevity in your answer.  1.00e+06. What is the average Aid flow from UN agencies (US$) in Ethiopia per year?
Offer a very short reply. 1.62e+07. What is the average Aid flow from UN agencies (US$) in Slovenia per year?
Your answer should be very brief. 1.05e+06. In the year 1997, what is the difference between the Aid flow from UN agencies (US$) of OECD members and Aid flow from UN agencies (US$) of Cameroon?
Your answer should be compact. 1.94e+07. In the year 1997, what is the difference between the Aid flow from UN agencies (US$) of OECD members and Aid flow from UN agencies (US$) of Ethiopia?
Your response must be concise. 2.40e+06. In the year 1997, what is the difference between the Aid flow from UN agencies (US$) in OECD members and Aid flow from UN agencies (US$) in Slovenia?
Provide a succinct answer. 1.81e+07. In the year 1997, what is the difference between the Aid flow from UN agencies (US$) of Cameroon and Aid flow from UN agencies (US$) of Ethiopia?
Your answer should be very brief. -1.70e+07. In the year 1997, what is the difference between the Aid flow from UN agencies (US$) of Cameroon and Aid flow from UN agencies (US$) of Slovenia?
Make the answer very short. -1.30e+06. In the year 1997, what is the difference between the Aid flow from UN agencies (US$) of Ethiopia and Aid flow from UN agencies (US$) of Slovenia?
Make the answer very short. 1.57e+07. In the year 1998, what is the difference between the Aid flow from UN agencies (US$) in OECD members and Aid flow from UN agencies (US$) in Cameroon?
Offer a very short reply. 1.80e+07. In the year 1998, what is the difference between the Aid flow from UN agencies (US$) of OECD members and Aid flow from UN agencies (US$) of Ethiopia?
Provide a succinct answer. 1.11e+06. In the year 1998, what is the difference between the Aid flow from UN agencies (US$) of OECD members and Aid flow from UN agencies (US$) of Slovenia?
Provide a short and direct response. 1.71e+07. In the year 1998, what is the difference between the Aid flow from UN agencies (US$) in Cameroon and Aid flow from UN agencies (US$) in Ethiopia?
Your response must be concise. -1.69e+07. In the year 1998, what is the difference between the Aid flow from UN agencies (US$) in Cameroon and Aid flow from UN agencies (US$) in Slovenia?
Your answer should be very brief. -9.00e+05. In the year 1998, what is the difference between the Aid flow from UN agencies (US$) of Ethiopia and Aid flow from UN agencies (US$) of Slovenia?
Give a very brief answer. 1.60e+07. In the year 1999, what is the difference between the Aid flow from UN agencies (US$) of OECD members and Aid flow from UN agencies (US$) of Cameroon?
Your answer should be compact. 1.69e+07. In the year 1999, what is the difference between the Aid flow from UN agencies (US$) in OECD members and Aid flow from UN agencies (US$) in Ethiopia?
Keep it short and to the point. 1.58e+06. In the year 1999, what is the difference between the Aid flow from UN agencies (US$) in OECD members and Aid flow from UN agencies (US$) in Slovenia?
Offer a terse response. 1.69e+07. In the year 1999, what is the difference between the Aid flow from UN agencies (US$) of Cameroon and Aid flow from UN agencies (US$) of Ethiopia?
Give a very brief answer. -1.54e+07. In the year 1999, what is the difference between the Aid flow from UN agencies (US$) of Cameroon and Aid flow from UN agencies (US$) of Slovenia?
Provide a short and direct response. -4.00e+04. In the year 1999, what is the difference between the Aid flow from UN agencies (US$) in Ethiopia and Aid flow from UN agencies (US$) in Slovenia?
Offer a very short reply. 1.53e+07. In the year 2000, what is the difference between the Aid flow from UN agencies (US$) in OECD members and Aid flow from UN agencies (US$) in Cameroon?
Offer a very short reply. 1.09e+07. In the year 2000, what is the difference between the Aid flow from UN agencies (US$) in OECD members and Aid flow from UN agencies (US$) in Ethiopia?
Provide a succinct answer. -4.76e+06. In the year 2000, what is the difference between the Aid flow from UN agencies (US$) in OECD members and Aid flow from UN agencies (US$) in Slovenia?
Offer a terse response. 1.08e+07. In the year 2000, what is the difference between the Aid flow from UN agencies (US$) in Cameroon and Aid flow from UN agencies (US$) in Ethiopia?
Your answer should be very brief. -1.56e+07. In the year 2000, what is the difference between the Aid flow from UN agencies (US$) in Ethiopia and Aid flow from UN agencies (US$) in Slovenia?
Give a very brief answer. 1.55e+07. In the year 2001, what is the difference between the Aid flow from UN agencies (US$) in OECD members and Aid flow from UN agencies (US$) in Cameroon?
Offer a terse response. 1.13e+07. In the year 2001, what is the difference between the Aid flow from UN agencies (US$) of OECD members and Aid flow from UN agencies (US$) of Ethiopia?
Ensure brevity in your answer.  -6.21e+06. In the year 2001, what is the difference between the Aid flow from UN agencies (US$) of OECD members and Aid flow from UN agencies (US$) of Slovenia?
Provide a short and direct response. 1.16e+07. In the year 2001, what is the difference between the Aid flow from UN agencies (US$) of Cameroon and Aid flow from UN agencies (US$) of Ethiopia?
Ensure brevity in your answer.  -1.76e+07. In the year 2001, what is the difference between the Aid flow from UN agencies (US$) of Ethiopia and Aid flow from UN agencies (US$) of Slovenia?
Offer a very short reply. 1.78e+07. In the year 2002, what is the difference between the Aid flow from UN agencies (US$) of OECD members and Aid flow from UN agencies (US$) of Cameroon?
Ensure brevity in your answer.  1.09e+07. In the year 2002, what is the difference between the Aid flow from UN agencies (US$) of OECD members and Aid flow from UN agencies (US$) of Ethiopia?
Give a very brief answer. -7.64e+06. In the year 2002, what is the difference between the Aid flow from UN agencies (US$) of OECD members and Aid flow from UN agencies (US$) of Slovenia?
Provide a succinct answer. 1.09e+07. In the year 2002, what is the difference between the Aid flow from UN agencies (US$) in Cameroon and Aid flow from UN agencies (US$) in Ethiopia?
Offer a very short reply. -1.86e+07. In the year 2002, what is the difference between the Aid flow from UN agencies (US$) of Cameroon and Aid flow from UN agencies (US$) of Slovenia?
Offer a terse response. -4.00e+04. In the year 2002, what is the difference between the Aid flow from UN agencies (US$) in Ethiopia and Aid flow from UN agencies (US$) in Slovenia?
Make the answer very short. 1.85e+07. In the year 2003, what is the difference between the Aid flow from UN agencies (US$) in OECD members and Aid flow from UN agencies (US$) in Cameroon?
Offer a very short reply. 8.74e+06. In the year 2003, what is the difference between the Aid flow from UN agencies (US$) in OECD members and Aid flow from UN agencies (US$) in Ethiopia?
Your answer should be very brief. -4.46e+06. In the year 2003, what is the difference between the Aid flow from UN agencies (US$) of OECD members and Aid flow from UN agencies (US$) of Slovenia?
Provide a succinct answer. 9.41e+06. In the year 2003, what is the difference between the Aid flow from UN agencies (US$) of Cameroon and Aid flow from UN agencies (US$) of Ethiopia?
Offer a terse response. -1.32e+07. In the year 2003, what is the difference between the Aid flow from UN agencies (US$) of Cameroon and Aid flow from UN agencies (US$) of Slovenia?
Provide a short and direct response. 6.70e+05. In the year 2003, what is the difference between the Aid flow from UN agencies (US$) in Ethiopia and Aid flow from UN agencies (US$) in Slovenia?
Offer a terse response. 1.39e+07. In the year 2004, what is the difference between the Aid flow from UN agencies (US$) in OECD members and Aid flow from UN agencies (US$) in Cameroon?
Your response must be concise. 1.10e+07. In the year 2004, what is the difference between the Aid flow from UN agencies (US$) of OECD members and Aid flow from UN agencies (US$) of Ethiopia?
Your response must be concise. 3.86e+06. In the year 2004, what is the difference between the Aid flow from UN agencies (US$) in OECD members and Aid flow from UN agencies (US$) in Slovenia?
Your response must be concise. 1.21e+07. In the year 2004, what is the difference between the Aid flow from UN agencies (US$) in Cameroon and Aid flow from UN agencies (US$) in Ethiopia?
Your answer should be compact. -7.15e+06. In the year 2004, what is the difference between the Aid flow from UN agencies (US$) in Cameroon and Aid flow from UN agencies (US$) in Slovenia?
Give a very brief answer. 1.10e+06. In the year 2004, what is the difference between the Aid flow from UN agencies (US$) of Ethiopia and Aid flow from UN agencies (US$) of Slovenia?
Provide a succinct answer. 8.25e+06. What is the ratio of the Aid flow from UN agencies (US$) in OECD members in 1997 to that in 1998?
Ensure brevity in your answer.  1.07. What is the ratio of the Aid flow from UN agencies (US$) of Cameroon in 1997 to that in 1998?
Ensure brevity in your answer.  1.03. What is the ratio of the Aid flow from UN agencies (US$) of Ethiopia in 1997 to that in 1998?
Your answer should be very brief. 1.01. What is the ratio of the Aid flow from UN agencies (US$) in Slovenia in 1997 to that in 1998?
Make the answer very short. 1.26. What is the ratio of the Aid flow from UN agencies (US$) of OECD members in 1997 to that in 1999?
Provide a succinct answer. 1.08. What is the ratio of the Aid flow from UN agencies (US$) in Cameroon in 1997 to that in 1999?
Give a very brief answer. 0.45. What is the ratio of the Aid flow from UN agencies (US$) in Ethiopia in 1997 to that in 1999?
Your answer should be very brief. 1.04. What is the ratio of the Aid flow from UN agencies (US$) of Slovenia in 1997 to that in 1999?
Your answer should be very brief. 1.22. What is the ratio of the Aid flow from UN agencies (US$) of OECD members in 1997 to that in 2000?
Your answer should be compact. 1.74. What is the ratio of the Aid flow from UN agencies (US$) of Cameroon in 1997 to that in 2000?
Give a very brief answer. 1.06. What is the ratio of the Aid flow from UN agencies (US$) of Ethiopia in 1997 to that in 2000?
Make the answer very short. 1.09. What is the ratio of the Aid flow from UN agencies (US$) of Slovenia in 1997 to that in 2000?
Your response must be concise. 2.66. What is the ratio of the Aid flow from UN agencies (US$) of OECD members in 1997 to that in 2001?
Provide a short and direct response. 1.65. What is the ratio of the Aid flow from UN agencies (US$) of Cameroon in 1997 to that in 2001?
Provide a succinct answer. 0.87. What is the ratio of the Aid flow from UN agencies (US$) of Ethiopia in 1997 to that in 2001?
Ensure brevity in your answer.  0.96. What is the ratio of the Aid flow from UN agencies (US$) of Slovenia in 1997 to that in 2001?
Keep it short and to the point. 3.31. What is the ratio of the Aid flow from UN agencies (US$) in OECD members in 1997 to that in 2002?
Give a very brief answer. 1.75. What is the ratio of the Aid flow from UN agencies (US$) of Cameroon in 1997 to that in 2002?
Make the answer very short. 1.24. What is the ratio of the Aid flow from UN agencies (US$) of Ethiopia in 1997 to that in 2002?
Provide a short and direct response. 0.92. What is the ratio of the Aid flow from UN agencies (US$) in Slovenia in 1997 to that in 2002?
Offer a very short reply. 3.26. What is the ratio of the Aid flow from UN agencies (US$) in OECD members in 1997 to that in 2003?
Offer a very short reply. 2.02. What is the ratio of the Aid flow from UN agencies (US$) of Cameroon in 1997 to that in 2003?
Provide a short and direct response. 0.6. What is the ratio of the Aid flow from UN agencies (US$) of Ethiopia in 1997 to that in 2003?
Your answer should be very brief. 1.23. What is the ratio of the Aid flow from UN agencies (US$) of Slovenia in 1997 to that in 2003?
Make the answer very short. 3.88. What is the ratio of the Aid flow from UN agencies (US$) in OECD members in 1997 to that in 2004?
Provide a succinct answer. 1.58. What is the ratio of the Aid flow from UN agencies (US$) of Cameroon in 1997 to that in 2004?
Your response must be concise. 0.43. What is the ratio of the Aid flow from UN agencies (US$) of Ethiopia in 1997 to that in 2004?
Your answer should be compact. 2. What is the ratio of the Aid flow from UN agencies (US$) of Slovenia in 1997 to that in 2004?
Your answer should be compact. 3.42. What is the ratio of the Aid flow from UN agencies (US$) of Cameroon in 1998 to that in 1999?
Give a very brief answer. 0.43. What is the ratio of the Aid flow from UN agencies (US$) of Ethiopia in 1998 to that in 1999?
Provide a short and direct response. 1.04. What is the ratio of the Aid flow from UN agencies (US$) of Slovenia in 1998 to that in 1999?
Your answer should be compact. 0.97. What is the ratio of the Aid flow from UN agencies (US$) of OECD members in 1998 to that in 2000?
Ensure brevity in your answer.  1.62. What is the ratio of the Aid flow from UN agencies (US$) in Cameroon in 1998 to that in 2000?
Make the answer very short. 1.03. What is the ratio of the Aid flow from UN agencies (US$) of Ethiopia in 1998 to that in 2000?
Give a very brief answer. 1.08. What is the ratio of the Aid flow from UN agencies (US$) of Slovenia in 1998 to that in 2000?
Provide a short and direct response. 2.11. What is the ratio of the Aid flow from UN agencies (US$) of OECD members in 1998 to that in 2001?
Offer a terse response. 1.54. What is the ratio of the Aid flow from UN agencies (US$) in Cameroon in 1998 to that in 2001?
Offer a very short reply. 0.84. What is the ratio of the Aid flow from UN agencies (US$) in Ethiopia in 1998 to that in 2001?
Offer a very short reply. 0.96. What is the ratio of the Aid flow from UN agencies (US$) in Slovenia in 1998 to that in 2001?
Keep it short and to the point. 2.62. What is the ratio of the Aid flow from UN agencies (US$) in OECD members in 1998 to that in 2002?
Ensure brevity in your answer.  1.62. What is the ratio of the Aid flow from UN agencies (US$) in Cameroon in 1998 to that in 2002?
Your response must be concise. 1.21. What is the ratio of the Aid flow from UN agencies (US$) of Ethiopia in 1998 to that in 2002?
Keep it short and to the point. 0.92. What is the ratio of the Aid flow from UN agencies (US$) in Slovenia in 1998 to that in 2002?
Give a very brief answer. 2.58. What is the ratio of the Aid flow from UN agencies (US$) of OECD members in 1998 to that in 2003?
Offer a very short reply. 1.88. What is the ratio of the Aid flow from UN agencies (US$) in Cameroon in 1998 to that in 2003?
Make the answer very short. 0.59. What is the ratio of the Aid flow from UN agencies (US$) of Ethiopia in 1998 to that in 2003?
Offer a very short reply. 1.22. What is the ratio of the Aid flow from UN agencies (US$) of Slovenia in 1998 to that in 2003?
Provide a succinct answer. 3.08. What is the ratio of the Aid flow from UN agencies (US$) of OECD members in 1998 to that in 2004?
Make the answer very short. 1.47. What is the ratio of the Aid flow from UN agencies (US$) of Cameroon in 1998 to that in 2004?
Provide a succinct answer. 0.41. What is the ratio of the Aid flow from UN agencies (US$) of Ethiopia in 1998 to that in 2004?
Give a very brief answer. 1.99. What is the ratio of the Aid flow from UN agencies (US$) of Slovenia in 1998 to that in 2004?
Offer a terse response. 2.71. What is the ratio of the Aid flow from UN agencies (US$) in OECD members in 1999 to that in 2000?
Make the answer very short. 1.61. What is the ratio of the Aid flow from UN agencies (US$) in Cameroon in 1999 to that in 2000?
Make the answer very short. 2.37. What is the ratio of the Aid flow from UN agencies (US$) of Ethiopia in 1999 to that in 2000?
Your response must be concise. 1.04. What is the ratio of the Aid flow from UN agencies (US$) of Slovenia in 1999 to that in 2000?
Your response must be concise. 2.17. What is the ratio of the Aid flow from UN agencies (US$) in OECD members in 1999 to that in 2001?
Your response must be concise. 1.52. What is the ratio of the Aid flow from UN agencies (US$) in Cameroon in 1999 to that in 2001?
Ensure brevity in your answer.  1.94. What is the ratio of the Aid flow from UN agencies (US$) of Ethiopia in 1999 to that in 2001?
Your answer should be very brief. 0.92. What is the ratio of the Aid flow from UN agencies (US$) of Slovenia in 1999 to that in 2001?
Provide a short and direct response. 2.7. What is the ratio of the Aid flow from UN agencies (US$) in OECD members in 1999 to that in 2002?
Your response must be concise. 1.61. What is the ratio of the Aid flow from UN agencies (US$) of Cameroon in 1999 to that in 2002?
Give a very brief answer. 2.78. What is the ratio of the Aid flow from UN agencies (US$) in Ethiopia in 1999 to that in 2002?
Provide a short and direct response. 0.89. What is the ratio of the Aid flow from UN agencies (US$) of Slovenia in 1999 to that in 2002?
Your answer should be very brief. 2.66. What is the ratio of the Aid flow from UN agencies (US$) of OECD members in 1999 to that in 2003?
Provide a succinct answer. 1.87. What is the ratio of the Aid flow from UN agencies (US$) in Cameroon in 1999 to that in 2003?
Provide a succinct answer. 1.35. What is the ratio of the Aid flow from UN agencies (US$) in Ethiopia in 1999 to that in 2003?
Give a very brief answer. 1.18. What is the ratio of the Aid flow from UN agencies (US$) in Slovenia in 1999 to that in 2003?
Offer a terse response. 3.17. What is the ratio of the Aid flow from UN agencies (US$) of OECD members in 1999 to that in 2004?
Give a very brief answer. 1.46. What is the ratio of the Aid flow from UN agencies (US$) of Cameroon in 1999 to that in 2004?
Offer a very short reply. 0.95. What is the ratio of the Aid flow from UN agencies (US$) in Ethiopia in 1999 to that in 2004?
Offer a terse response. 1.92. What is the ratio of the Aid flow from UN agencies (US$) in Slovenia in 1999 to that in 2004?
Give a very brief answer. 2.8. What is the ratio of the Aid flow from UN agencies (US$) of OECD members in 2000 to that in 2001?
Offer a very short reply. 0.95. What is the ratio of the Aid flow from UN agencies (US$) in Cameroon in 2000 to that in 2001?
Offer a very short reply. 0.82. What is the ratio of the Aid flow from UN agencies (US$) in Ethiopia in 2000 to that in 2001?
Make the answer very short. 0.89. What is the ratio of the Aid flow from UN agencies (US$) in Slovenia in 2000 to that in 2001?
Your answer should be very brief. 1.25. What is the ratio of the Aid flow from UN agencies (US$) in Cameroon in 2000 to that in 2002?
Provide a short and direct response. 1.17. What is the ratio of the Aid flow from UN agencies (US$) of Ethiopia in 2000 to that in 2002?
Make the answer very short. 0.85. What is the ratio of the Aid flow from UN agencies (US$) of Slovenia in 2000 to that in 2002?
Your answer should be very brief. 1.23. What is the ratio of the Aid flow from UN agencies (US$) in OECD members in 2000 to that in 2003?
Your response must be concise. 1.16. What is the ratio of the Aid flow from UN agencies (US$) in Ethiopia in 2000 to that in 2003?
Your answer should be compact. 1.13. What is the ratio of the Aid flow from UN agencies (US$) of Slovenia in 2000 to that in 2003?
Your response must be concise. 1.46. What is the ratio of the Aid flow from UN agencies (US$) of OECD members in 2000 to that in 2004?
Ensure brevity in your answer.  0.91. What is the ratio of the Aid flow from UN agencies (US$) of Cameroon in 2000 to that in 2004?
Make the answer very short. 0.4. What is the ratio of the Aid flow from UN agencies (US$) of Ethiopia in 2000 to that in 2004?
Ensure brevity in your answer.  1.84. What is the ratio of the Aid flow from UN agencies (US$) of Slovenia in 2000 to that in 2004?
Your answer should be very brief. 1.29. What is the ratio of the Aid flow from UN agencies (US$) of OECD members in 2001 to that in 2002?
Keep it short and to the point. 1.06. What is the ratio of the Aid flow from UN agencies (US$) in Cameroon in 2001 to that in 2002?
Your response must be concise. 1.43. What is the ratio of the Aid flow from UN agencies (US$) of Ethiopia in 2001 to that in 2002?
Provide a short and direct response. 0.96. What is the ratio of the Aid flow from UN agencies (US$) of Slovenia in 2001 to that in 2002?
Provide a succinct answer. 0.98. What is the ratio of the Aid flow from UN agencies (US$) in OECD members in 2001 to that in 2003?
Keep it short and to the point. 1.23. What is the ratio of the Aid flow from UN agencies (US$) in Cameroon in 2001 to that in 2003?
Give a very brief answer. 0.7. What is the ratio of the Aid flow from UN agencies (US$) of Ethiopia in 2001 to that in 2003?
Provide a succinct answer. 1.28. What is the ratio of the Aid flow from UN agencies (US$) in Slovenia in 2001 to that in 2003?
Provide a succinct answer. 1.17. What is the ratio of the Aid flow from UN agencies (US$) in OECD members in 2001 to that in 2004?
Ensure brevity in your answer.  0.96. What is the ratio of the Aid flow from UN agencies (US$) in Cameroon in 2001 to that in 2004?
Offer a terse response. 0.49. What is the ratio of the Aid flow from UN agencies (US$) in Ethiopia in 2001 to that in 2004?
Provide a short and direct response. 2.08. What is the ratio of the Aid flow from UN agencies (US$) of Slovenia in 2001 to that in 2004?
Keep it short and to the point. 1.03. What is the ratio of the Aid flow from UN agencies (US$) of OECD members in 2002 to that in 2003?
Ensure brevity in your answer.  1.16. What is the ratio of the Aid flow from UN agencies (US$) in Cameroon in 2002 to that in 2003?
Keep it short and to the point. 0.49. What is the ratio of the Aid flow from UN agencies (US$) of Ethiopia in 2002 to that in 2003?
Your answer should be very brief. 1.33. What is the ratio of the Aid flow from UN agencies (US$) in Slovenia in 2002 to that in 2003?
Keep it short and to the point. 1.19. What is the ratio of the Aid flow from UN agencies (US$) in OECD members in 2002 to that in 2004?
Provide a succinct answer. 0.91. What is the ratio of the Aid flow from UN agencies (US$) in Cameroon in 2002 to that in 2004?
Your response must be concise. 0.34. What is the ratio of the Aid flow from UN agencies (US$) in Ethiopia in 2002 to that in 2004?
Ensure brevity in your answer.  2.17. What is the ratio of the Aid flow from UN agencies (US$) in Slovenia in 2002 to that in 2004?
Provide a short and direct response. 1.05. What is the ratio of the Aid flow from UN agencies (US$) of OECD members in 2003 to that in 2004?
Provide a succinct answer. 0.78. What is the ratio of the Aid flow from UN agencies (US$) of Cameroon in 2003 to that in 2004?
Offer a terse response. 0.7. What is the ratio of the Aid flow from UN agencies (US$) in Ethiopia in 2003 to that in 2004?
Provide a short and direct response. 1.63. What is the ratio of the Aid flow from UN agencies (US$) in Slovenia in 2003 to that in 2004?
Ensure brevity in your answer.  0.88. What is the difference between the highest and the second highest Aid flow from UN agencies (US$) of OECD members?
Keep it short and to the point. 1.40e+06. What is the difference between the highest and the second highest Aid flow from UN agencies (US$) in Ethiopia?
Provide a short and direct response. 7.70e+05. What is the difference between the highest and the second highest Aid flow from UN agencies (US$) in Slovenia?
Keep it short and to the point. 3.70e+05. What is the difference between the highest and the lowest Aid flow from UN agencies (US$) of OECD members?
Ensure brevity in your answer.  1.02e+07. What is the difference between the highest and the lowest Aid flow from UN agencies (US$) of Cameroon?
Offer a terse response. 1.11e+06. What is the difference between the highest and the lowest Aid flow from UN agencies (US$) in Ethiopia?
Provide a succinct answer. 1.03e+07. What is the difference between the highest and the lowest Aid flow from UN agencies (US$) in Slovenia?
Offer a terse response. 1.50e+06. 